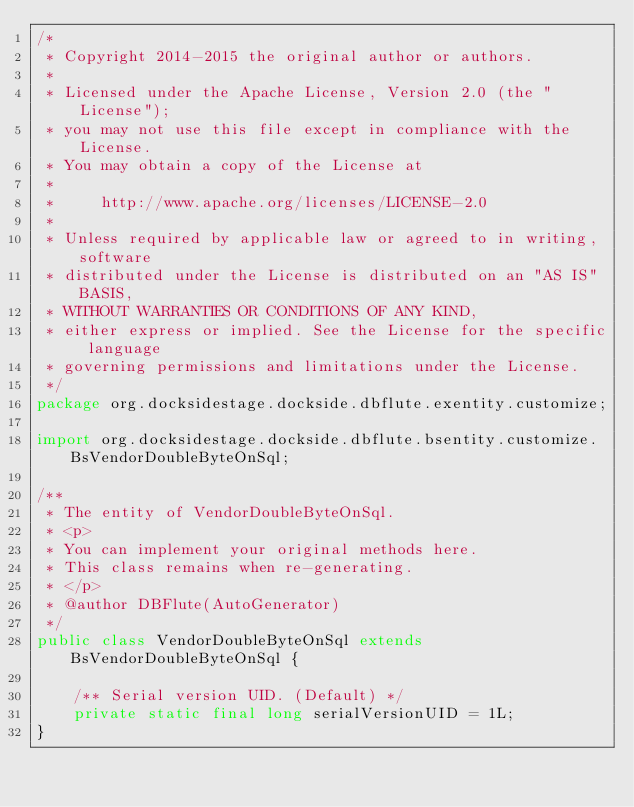Convert code to text. <code><loc_0><loc_0><loc_500><loc_500><_Java_>/*
 * Copyright 2014-2015 the original author or authors.
 *
 * Licensed under the Apache License, Version 2.0 (the "License");
 * you may not use this file except in compliance with the License.
 * You may obtain a copy of the License at
 *
 *     http://www.apache.org/licenses/LICENSE-2.0
 *
 * Unless required by applicable law or agreed to in writing, software
 * distributed under the License is distributed on an "AS IS" BASIS,
 * WITHOUT WARRANTIES OR CONDITIONS OF ANY KIND,
 * either express or implied. See the License for the specific language
 * governing permissions and limitations under the License.
 */
package org.docksidestage.dockside.dbflute.exentity.customize;

import org.docksidestage.dockside.dbflute.bsentity.customize.BsVendorDoubleByteOnSql;

/**
 * The entity of VendorDoubleByteOnSql.
 * <p>
 * You can implement your original methods here.
 * This class remains when re-generating.
 * </p>
 * @author DBFlute(AutoGenerator)
 */
public class VendorDoubleByteOnSql extends BsVendorDoubleByteOnSql {

    /** Serial version UID. (Default) */
    private static final long serialVersionUID = 1L;
}
</code> 